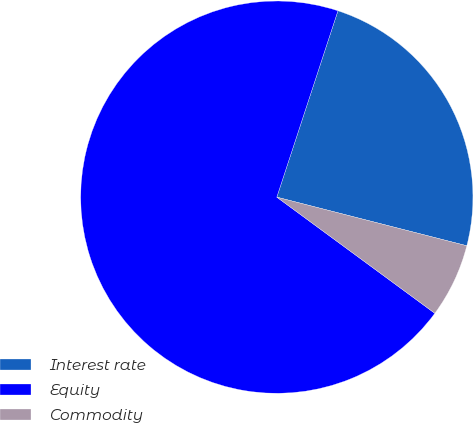<chart> <loc_0><loc_0><loc_500><loc_500><pie_chart><fcel>Interest rate<fcel>Equity<fcel>Commodity<nl><fcel>23.94%<fcel>69.95%<fcel>6.1%<nl></chart> 